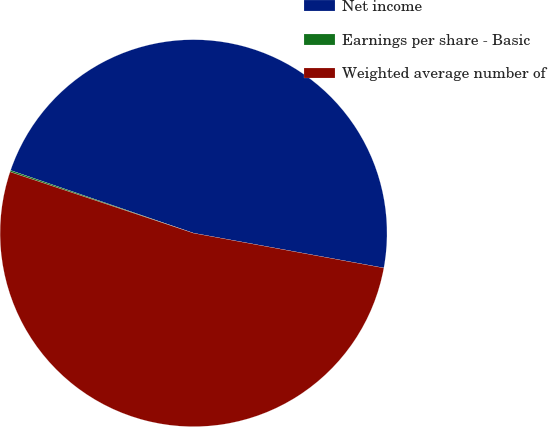Convert chart. <chart><loc_0><loc_0><loc_500><loc_500><pie_chart><fcel>Net income<fcel>Earnings per share - Basic<fcel>Weighted average number of<nl><fcel>47.62%<fcel>0.13%<fcel>52.25%<nl></chart> 